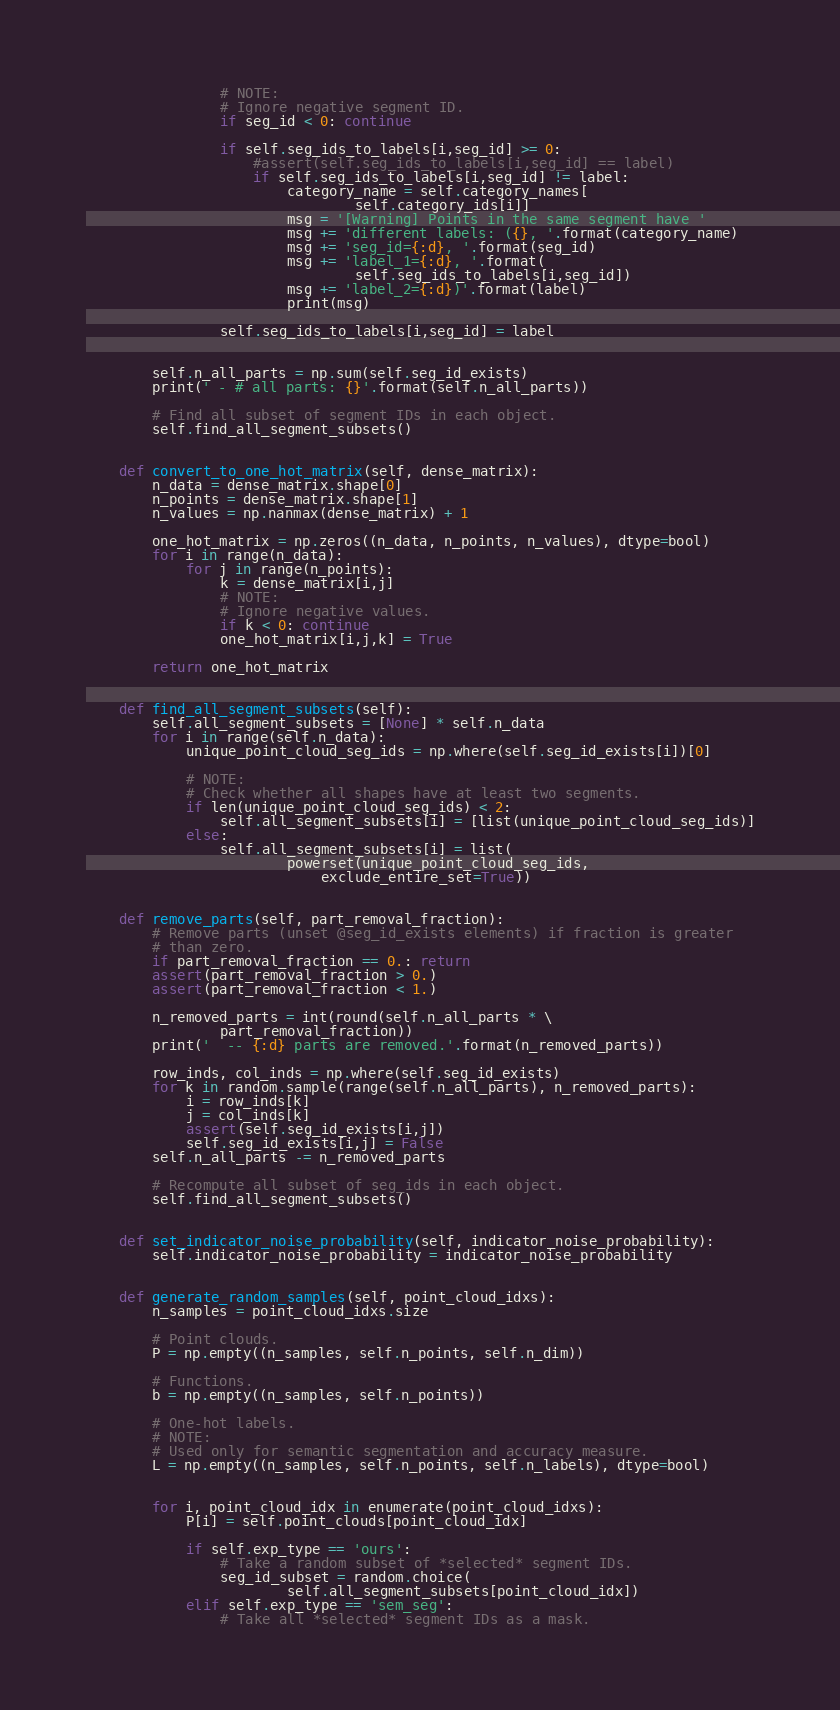Convert code to text. <code><loc_0><loc_0><loc_500><loc_500><_Python_>                # NOTE:
                # Ignore negative segment ID.
                if seg_id < 0: continue

                if self.seg_ids_to_labels[i,seg_id] >= 0:
                    #assert(self.seg_ids_to_labels[i,seg_id] == label)
                    if self.seg_ids_to_labels[i,seg_id] != label:
                        category_name = self.category_names[
                                self.category_ids[i]]
                        msg = '[Warning] Points in the same segment have '
                        msg += 'different labels: ({}, '.format(category_name)
                        msg += 'seg_id={:d}, '.format(seg_id)
                        msg += 'label_1={:d}, '.format(
                                self.seg_ids_to_labels[i,seg_id])
                        msg += 'label_2={:d})'.format(label)
                        print(msg)

                self.seg_ids_to_labels[i,seg_id] = label


        self.n_all_parts = np.sum(self.seg_id_exists)
        print(' - # all parts: {}'.format(self.n_all_parts))

        # Find all subset of segment IDs in each object.
        self.find_all_segment_subsets()


    def convert_to_one_hot_matrix(self, dense_matrix):
        n_data = dense_matrix.shape[0]
        n_points = dense_matrix.shape[1]
        n_values = np.nanmax(dense_matrix) + 1

        one_hot_matrix = np.zeros((n_data, n_points, n_values), dtype=bool)
        for i in range(n_data):
            for j in range(n_points):
                k = dense_matrix[i,j]
                # NOTE:
                # Ignore negative values.
                if k < 0: continue
                one_hot_matrix[i,j,k] = True

        return one_hot_matrix


    def find_all_segment_subsets(self):
        self.all_segment_subsets = [None] * self.n_data
        for i in range(self.n_data):
            unique_point_cloud_seg_ids = np.where(self.seg_id_exists[i])[0]

            # NOTE:
            # Check whether all shapes have at least two segments.
            if len(unique_point_cloud_seg_ids) < 2:
                self.all_segment_subsets[i] = [list(unique_point_cloud_seg_ids)]
            else:
                self.all_segment_subsets[i] = list(
                        powerset(unique_point_cloud_seg_ids,
                            exclude_entire_set=True))


    def remove_parts(self, part_removal_fraction):
        # Remove parts (unset @seg_id_exists elements) if fraction is greater
        # than zero.
        if part_removal_fraction == 0.: return
        assert(part_removal_fraction > 0.)
        assert(part_removal_fraction < 1.)

        n_removed_parts = int(round(self.n_all_parts * \
                part_removal_fraction))
        print('  -- {:d} parts are removed.'.format(n_removed_parts))

        row_inds, col_inds = np.where(self.seg_id_exists)
        for k in random.sample(range(self.n_all_parts), n_removed_parts):
            i = row_inds[k]
            j = col_inds[k]
            assert(self.seg_id_exists[i,j])
            self.seg_id_exists[i,j] = False
        self.n_all_parts -= n_removed_parts

        # Recompute all subset of seg_ids in each object.
        self.find_all_segment_subsets()


    def set_indicator_noise_probability(self, indicator_noise_probability):
        self.indicator_noise_probability = indicator_noise_probability


    def generate_random_samples(self, point_cloud_idxs):
        n_samples = point_cloud_idxs.size

        # Point clouds.
        P = np.empty((n_samples, self.n_points, self.n_dim))

        # Functions.
        b = np.empty((n_samples, self.n_points))

        # One-hot labels.
        # NOTE:
        # Used only for semantic segmentation and accuracy measure.
        L = np.empty((n_samples, self.n_points, self.n_labels), dtype=bool)


        for i, point_cloud_idx in enumerate(point_cloud_idxs):
            P[i] = self.point_clouds[point_cloud_idx]

            if self.exp_type == 'ours':
                # Take a random subset of *selected* segment IDs.
                seg_id_subset = random.choice(
                        self.all_segment_subsets[point_cloud_idx])
            elif self.exp_type == 'sem_seg':
                # Take all *selected* segment IDs as a mask.</code> 